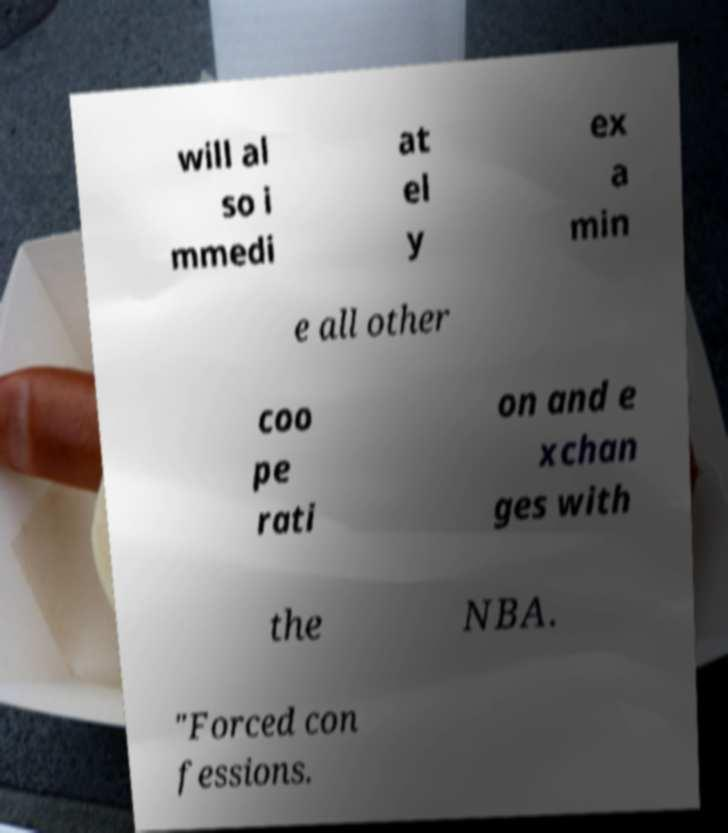Could you extract and type out the text from this image? will al so i mmedi at el y ex a min e all other coo pe rati on and e xchan ges with the NBA. "Forced con fessions. 